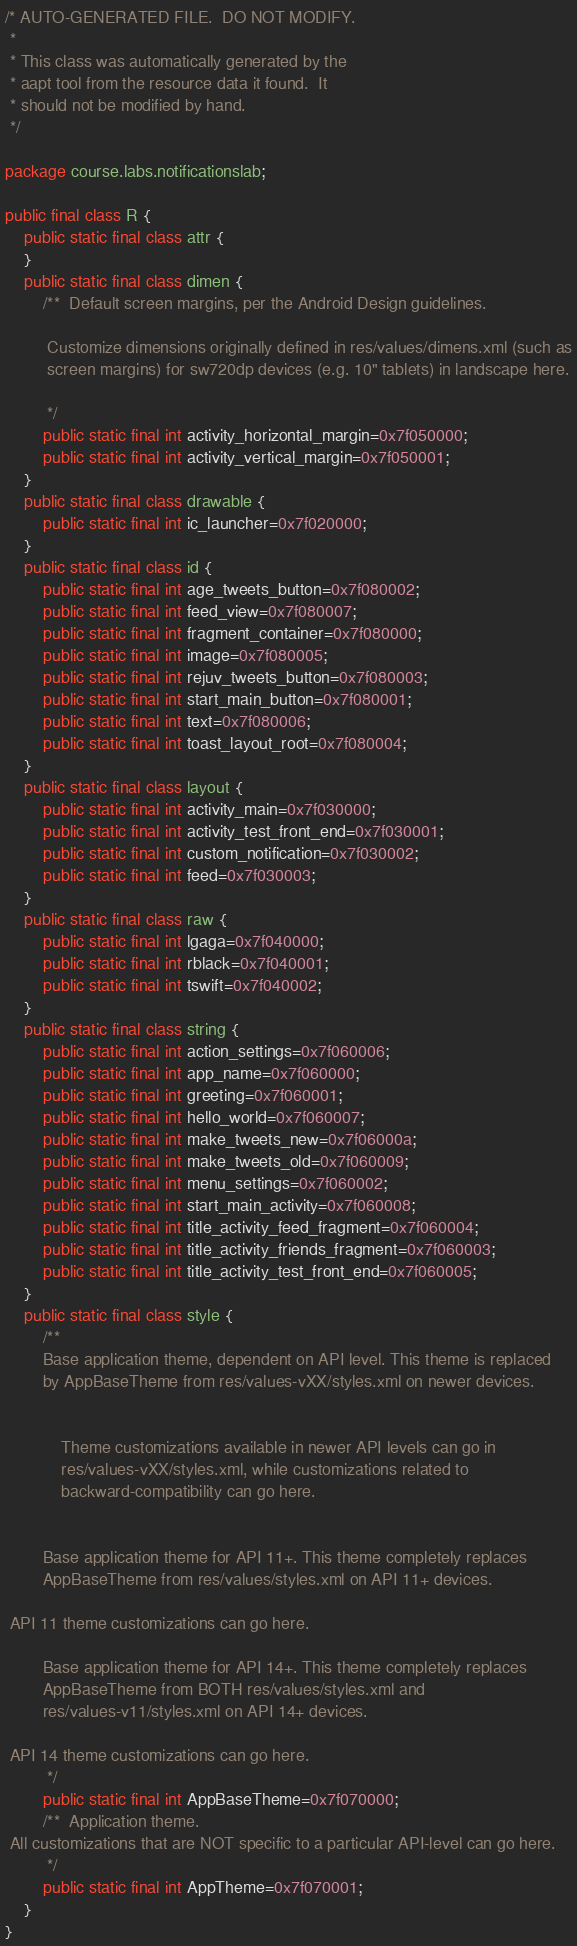Convert code to text. <code><loc_0><loc_0><loc_500><loc_500><_Java_>/* AUTO-GENERATED FILE.  DO NOT MODIFY.
 *
 * This class was automatically generated by the
 * aapt tool from the resource data it found.  It
 * should not be modified by hand.
 */

package course.labs.notificationslab;

public final class R {
    public static final class attr {
    }
    public static final class dimen {
        /**  Default screen margins, per the Android Design guidelines. 

         Customize dimensions originally defined in res/values/dimens.xml (such as
         screen margins) for sw720dp devices (e.g. 10" tablets) in landscape here.
    
         */
        public static final int activity_horizontal_margin=0x7f050000;
        public static final int activity_vertical_margin=0x7f050001;
    }
    public static final class drawable {
        public static final int ic_launcher=0x7f020000;
    }
    public static final class id {
        public static final int age_tweets_button=0x7f080002;
        public static final int feed_view=0x7f080007;
        public static final int fragment_container=0x7f080000;
        public static final int image=0x7f080005;
        public static final int rejuv_tweets_button=0x7f080003;
        public static final int start_main_button=0x7f080001;
        public static final int text=0x7f080006;
        public static final int toast_layout_root=0x7f080004;
    }
    public static final class layout {
        public static final int activity_main=0x7f030000;
        public static final int activity_test_front_end=0x7f030001;
        public static final int custom_notification=0x7f030002;
        public static final int feed=0x7f030003;
    }
    public static final class raw {
        public static final int lgaga=0x7f040000;
        public static final int rblack=0x7f040001;
        public static final int tswift=0x7f040002;
    }
    public static final class string {
        public static final int action_settings=0x7f060006;
        public static final int app_name=0x7f060000;
        public static final int greeting=0x7f060001;
        public static final int hello_world=0x7f060007;
        public static final int make_tweets_new=0x7f06000a;
        public static final int make_tweets_old=0x7f060009;
        public static final int menu_settings=0x7f060002;
        public static final int start_main_activity=0x7f060008;
        public static final int title_activity_feed_fragment=0x7f060004;
        public static final int title_activity_friends_fragment=0x7f060003;
        public static final int title_activity_test_front_end=0x7f060005;
    }
    public static final class style {
        /** 
        Base application theme, dependent on API level. This theme is replaced
        by AppBaseTheme from res/values-vXX/styles.xml on newer devices.
    

            Theme customizations available in newer API levels can go in
            res/values-vXX/styles.xml, while customizations related to
            backward-compatibility can go here.
        

        Base application theme for API 11+. This theme completely replaces
        AppBaseTheme from res/values/styles.xml on API 11+ devices.
    
 API 11 theme customizations can go here. 

        Base application theme for API 14+. This theme completely replaces
        AppBaseTheme from BOTH res/values/styles.xml and
        res/values-v11/styles.xml on API 14+ devices.
    
 API 14 theme customizations can go here. 
         */
        public static final int AppBaseTheme=0x7f070000;
        /**  Application theme. 
 All customizations that are NOT specific to a particular API-level can go here. 
         */
        public static final int AppTheme=0x7f070001;
    }
}
</code> 